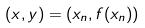Convert formula to latex. <formula><loc_0><loc_0><loc_500><loc_500>( x , y ) = ( x _ { n } , f ( x _ { n } ) )</formula> 